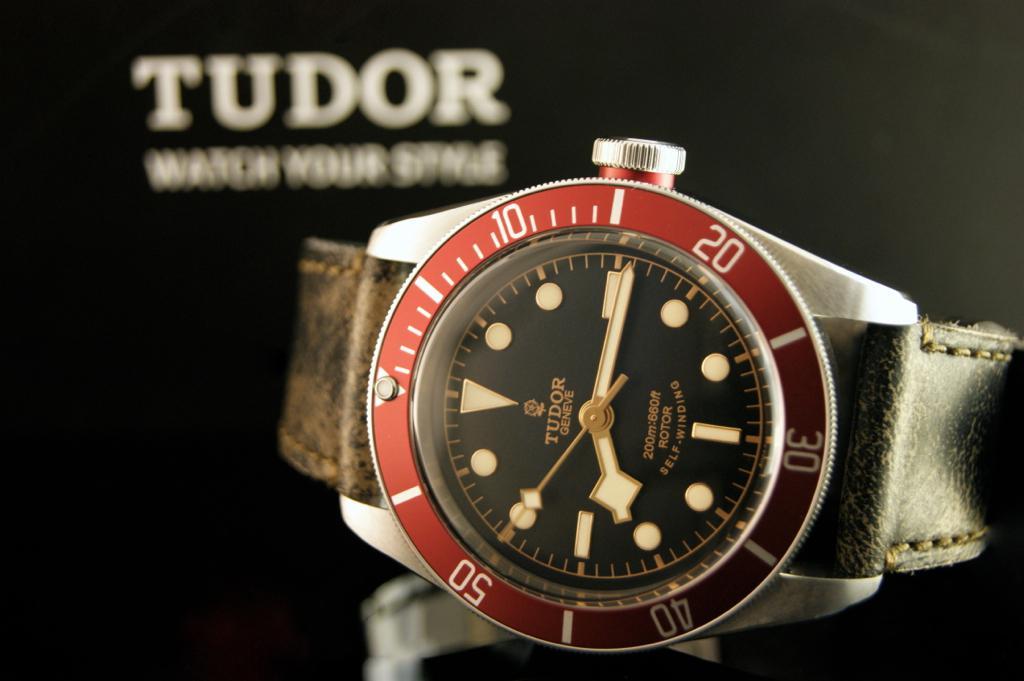What is the time right now?
Provide a succinct answer. 8:15. What is the brand name of the watch?
Make the answer very short. Tudor. 